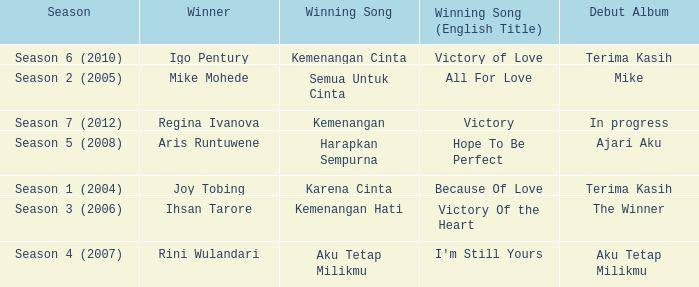Which album debuted in season 2 (2005)? Mike. 